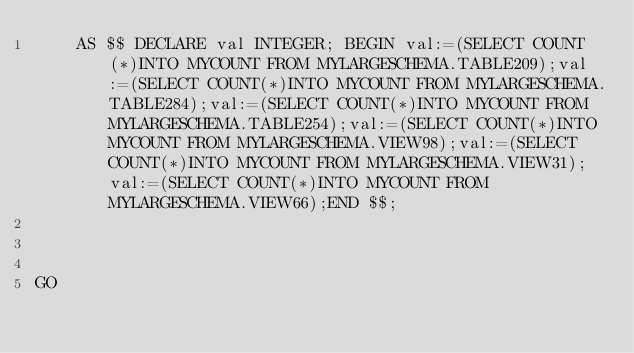Convert code to text. <code><loc_0><loc_0><loc_500><loc_500><_SQL_>    AS $$ DECLARE val INTEGER; BEGIN val:=(SELECT COUNT(*)INTO MYCOUNT FROM MYLARGESCHEMA.TABLE209);val:=(SELECT COUNT(*)INTO MYCOUNT FROM MYLARGESCHEMA.TABLE284);val:=(SELECT COUNT(*)INTO MYCOUNT FROM MYLARGESCHEMA.TABLE254);val:=(SELECT COUNT(*)INTO MYCOUNT FROM MYLARGESCHEMA.VIEW98);val:=(SELECT COUNT(*)INTO MYCOUNT FROM MYLARGESCHEMA.VIEW31);val:=(SELECT COUNT(*)INTO MYCOUNT FROM MYLARGESCHEMA.VIEW66);END $$;



GO</code> 